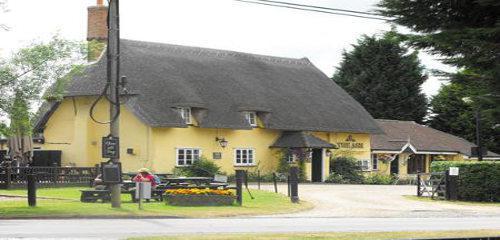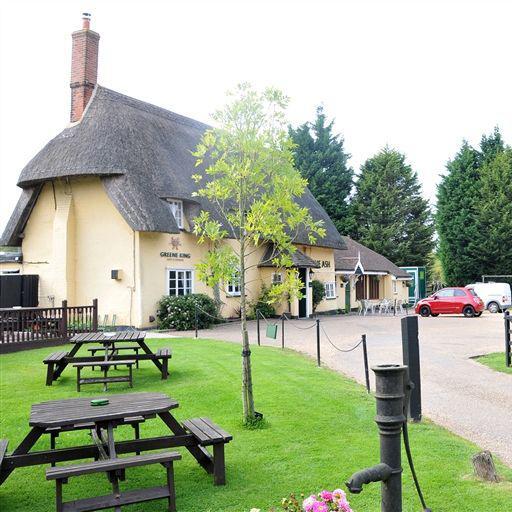The first image is the image on the left, the second image is the image on the right. Considering the images on both sides, is "A red chimney rises from a yellow building with a thatched roof." valid? Answer yes or no. Yes. The first image is the image on the left, the second image is the image on the right. Assess this claim about the two images: "Each image shows a large building with a chimney sticking out of a non-shingle roof and multiple picnic tables situated near it.". Correct or not? Answer yes or no. Yes. 